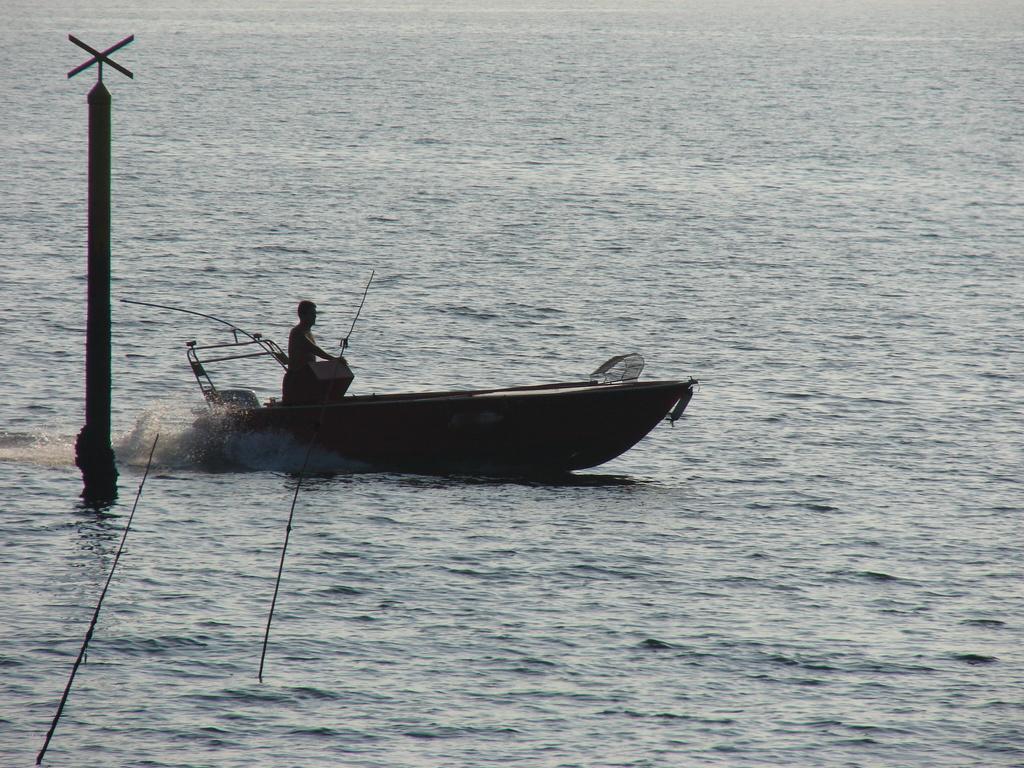Can you describe this image briefly? In this image there is a person standing on the boat, which is on the river and there is like a pole. 